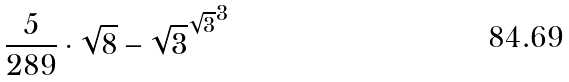Convert formula to latex. <formula><loc_0><loc_0><loc_500><loc_500>\frac { 5 } { 2 8 9 } \cdot \sqrt { 8 } - { \sqrt { 3 } ^ { \sqrt { 3 } } } ^ { 3 }</formula> 